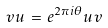Convert formula to latex. <formula><loc_0><loc_0><loc_500><loc_500>v u \, = \, e ^ { 2 \pi i \theta } u v</formula> 